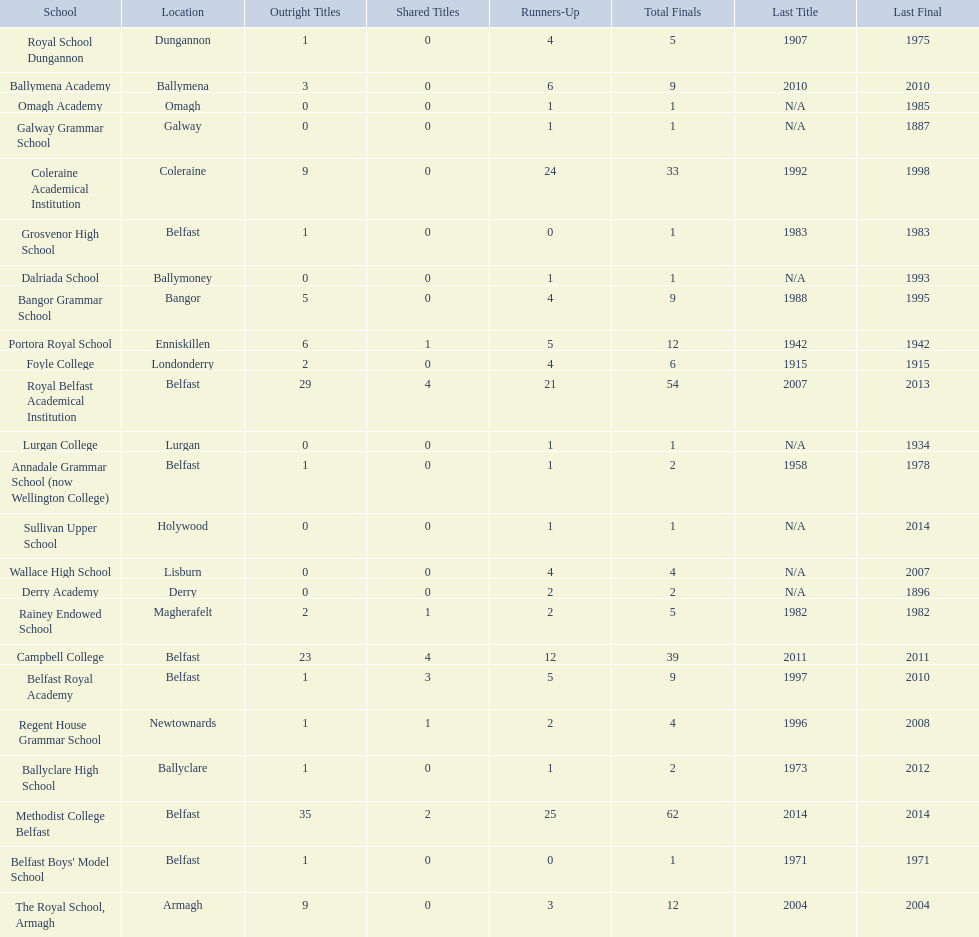Which schools have the largest number of shared titles? Royal Belfast Academical Institution, Campbell College. 